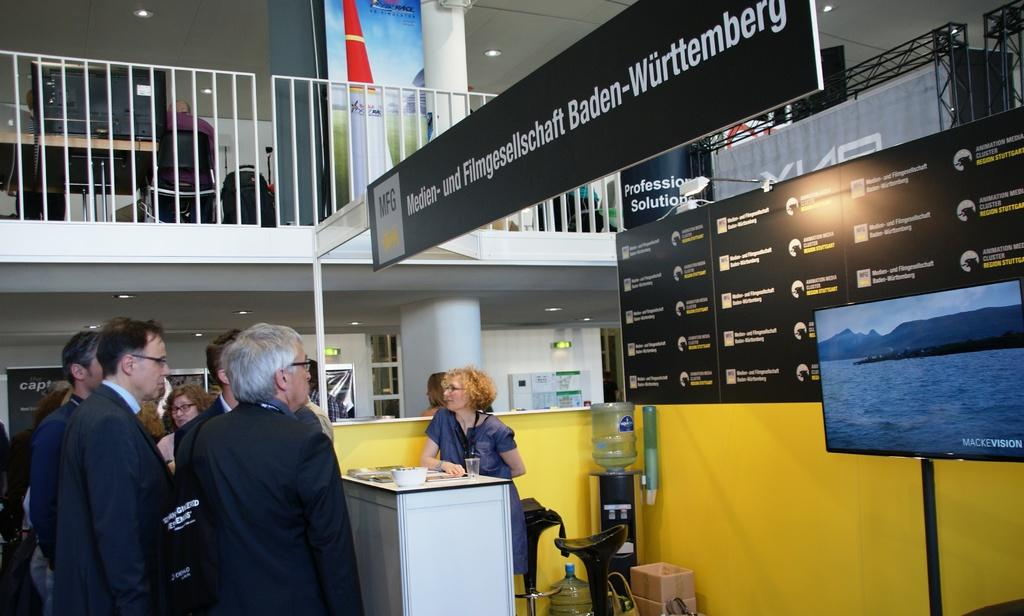<image>
Relay a brief, clear account of the picture shown. people at a display with a sign reading MFG 